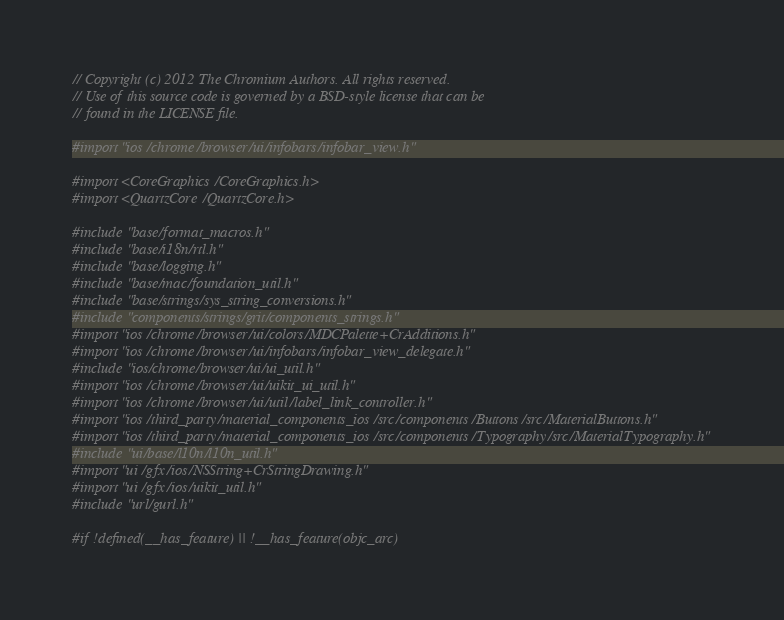<code> <loc_0><loc_0><loc_500><loc_500><_ObjectiveC_>// Copyright (c) 2012 The Chromium Authors. All rights reserved.
// Use of this source code is governed by a BSD-style license that can be
// found in the LICENSE file.

#import "ios/chrome/browser/ui/infobars/infobar_view.h"

#import <CoreGraphics/CoreGraphics.h>
#import <QuartzCore/QuartzCore.h>

#include "base/format_macros.h"
#include "base/i18n/rtl.h"
#include "base/logging.h"
#include "base/mac/foundation_util.h"
#include "base/strings/sys_string_conversions.h"
#include "components/strings/grit/components_strings.h"
#import "ios/chrome/browser/ui/colors/MDCPalette+CrAdditions.h"
#import "ios/chrome/browser/ui/infobars/infobar_view_delegate.h"
#include "ios/chrome/browser/ui/ui_util.h"
#import "ios/chrome/browser/ui/uikit_ui_util.h"
#import "ios/chrome/browser/ui/util/label_link_controller.h"
#import "ios/third_party/material_components_ios/src/components/Buttons/src/MaterialButtons.h"
#import "ios/third_party/material_components_ios/src/components/Typography/src/MaterialTypography.h"
#include "ui/base/l10n/l10n_util.h"
#import "ui/gfx/ios/NSString+CrStringDrawing.h"
#import "ui/gfx/ios/uikit_util.h"
#include "url/gurl.h"

#if !defined(__has_feature) || !__has_feature(objc_arc)</code> 